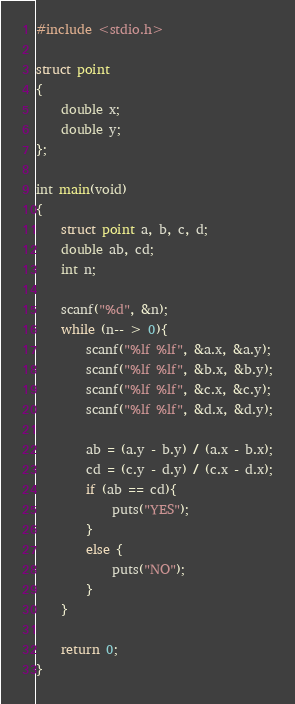<code> <loc_0><loc_0><loc_500><loc_500><_C_>#include <stdio.h>

struct point
{
	double x;
	double y;
};

int main(void)
{
	struct point a, b, c, d;
	double ab, cd;
	int n;
	
	scanf("%d", &n);
	while (n-- > 0){
		scanf("%lf %lf", &a.x, &a.y);
		scanf("%lf %lf", &b.x, &b.y);
		scanf("%lf %lf", &c.x, &c.y);
		scanf("%lf %lf", &d.x, &d.y);
		
		ab = (a.y - b.y) / (a.x - b.x);
		cd = (c.y - d.y) / (c.x - d.x);
		if (ab == cd){
			puts("YES");
		}
		else {
			puts("NO");
		}
	}
	
	return 0;
}</code> 